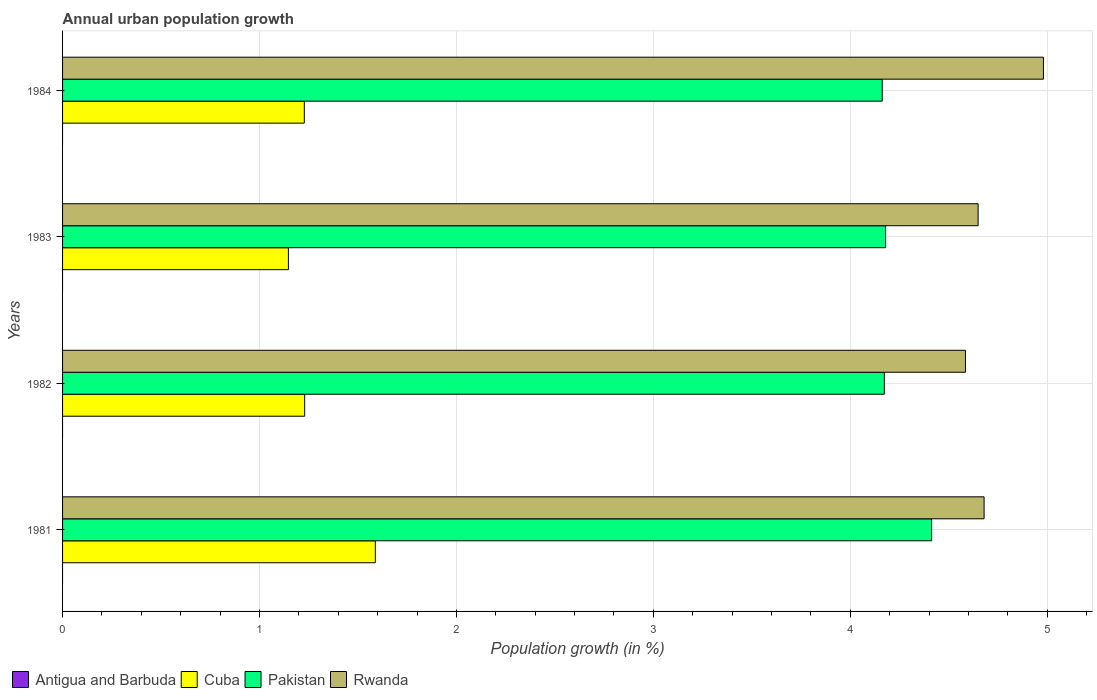Are the number of bars on each tick of the Y-axis equal?
Keep it short and to the point. Yes. What is the label of the 1st group of bars from the top?
Your answer should be very brief. 1984. In how many cases, is the number of bars for a given year not equal to the number of legend labels?
Keep it short and to the point. 4. What is the percentage of urban population growth in Cuba in 1981?
Provide a short and direct response. 1.59. Across all years, what is the maximum percentage of urban population growth in Cuba?
Make the answer very short. 1.59. Across all years, what is the minimum percentage of urban population growth in Rwanda?
Offer a terse response. 4.58. What is the total percentage of urban population growth in Rwanda in the graph?
Ensure brevity in your answer.  18.89. What is the difference between the percentage of urban population growth in Rwanda in 1981 and that in 1982?
Give a very brief answer. 0.09. What is the difference between the percentage of urban population growth in Cuba in 1982 and the percentage of urban population growth in Rwanda in 1984?
Make the answer very short. -3.75. What is the average percentage of urban population growth in Rwanda per year?
Give a very brief answer. 4.72. In the year 1983, what is the difference between the percentage of urban population growth in Rwanda and percentage of urban population growth in Cuba?
Keep it short and to the point. 3.5. What is the ratio of the percentage of urban population growth in Pakistan in 1982 to that in 1983?
Your response must be concise. 1. Is the percentage of urban population growth in Pakistan in 1982 less than that in 1984?
Offer a terse response. No. Is the difference between the percentage of urban population growth in Rwanda in 1981 and 1982 greater than the difference between the percentage of urban population growth in Cuba in 1981 and 1982?
Make the answer very short. No. What is the difference between the highest and the second highest percentage of urban population growth in Pakistan?
Give a very brief answer. 0.23. What is the difference between the highest and the lowest percentage of urban population growth in Rwanda?
Give a very brief answer. 0.4. In how many years, is the percentage of urban population growth in Cuba greater than the average percentage of urban population growth in Cuba taken over all years?
Give a very brief answer. 1. Is the sum of the percentage of urban population growth in Rwanda in 1981 and 1984 greater than the maximum percentage of urban population growth in Pakistan across all years?
Your response must be concise. Yes. Is it the case that in every year, the sum of the percentage of urban population growth in Antigua and Barbuda and percentage of urban population growth in Cuba is greater than the percentage of urban population growth in Pakistan?
Offer a terse response. No. Are all the bars in the graph horizontal?
Give a very brief answer. Yes. What is the difference between two consecutive major ticks on the X-axis?
Your answer should be very brief. 1. Does the graph contain grids?
Provide a succinct answer. Yes. How many legend labels are there?
Make the answer very short. 4. What is the title of the graph?
Ensure brevity in your answer.  Annual urban population growth. What is the label or title of the X-axis?
Your answer should be very brief. Population growth (in %). What is the Population growth (in %) in Cuba in 1981?
Provide a short and direct response. 1.59. What is the Population growth (in %) in Pakistan in 1981?
Ensure brevity in your answer.  4.41. What is the Population growth (in %) of Rwanda in 1981?
Make the answer very short. 4.68. What is the Population growth (in %) in Cuba in 1982?
Your answer should be compact. 1.23. What is the Population growth (in %) of Pakistan in 1982?
Provide a succinct answer. 4.17. What is the Population growth (in %) in Rwanda in 1982?
Provide a succinct answer. 4.58. What is the Population growth (in %) of Cuba in 1983?
Your answer should be very brief. 1.15. What is the Population growth (in %) of Pakistan in 1983?
Offer a very short reply. 4.18. What is the Population growth (in %) of Rwanda in 1983?
Offer a terse response. 4.65. What is the Population growth (in %) in Cuba in 1984?
Make the answer very short. 1.23. What is the Population growth (in %) of Pakistan in 1984?
Ensure brevity in your answer.  4.16. What is the Population growth (in %) in Rwanda in 1984?
Provide a succinct answer. 4.98. Across all years, what is the maximum Population growth (in %) of Cuba?
Give a very brief answer. 1.59. Across all years, what is the maximum Population growth (in %) of Pakistan?
Your answer should be very brief. 4.41. Across all years, what is the maximum Population growth (in %) of Rwanda?
Provide a succinct answer. 4.98. Across all years, what is the minimum Population growth (in %) in Cuba?
Make the answer very short. 1.15. Across all years, what is the minimum Population growth (in %) of Pakistan?
Your answer should be very brief. 4.16. Across all years, what is the minimum Population growth (in %) in Rwanda?
Keep it short and to the point. 4.58. What is the total Population growth (in %) in Cuba in the graph?
Give a very brief answer. 5.19. What is the total Population growth (in %) in Pakistan in the graph?
Make the answer very short. 16.93. What is the total Population growth (in %) in Rwanda in the graph?
Your response must be concise. 18.89. What is the difference between the Population growth (in %) of Cuba in 1981 and that in 1982?
Offer a terse response. 0.36. What is the difference between the Population growth (in %) in Pakistan in 1981 and that in 1982?
Your answer should be compact. 0.24. What is the difference between the Population growth (in %) in Rwanda in 1981 and that in 1982?
Offer a terse response. 0.09. What is the difference between the Population growth (in %) in Cuba in 1981 and that in 1983?
Your answer should be very brief. 0.44. What is the difference between the Population growth (in %) in Pakistan in 1981 and that in 1983?
Keep it short and to the point. 0.23. What is the difference between the Population growth (in %) in Rwanda in 1981 and that in 1983?
Give a very brief answer. 0.03. What is the difference between the Population growth (in %) in Cuba in 1981 and that in 1984?
Your answer should be compact. 0.36. What is the difference between the Population growth (in %) in Pakistan in 1981 and that in 1984?
Provide a succinct answer. 0.25. What is the difference between the Population growth (in %) of Rwanda in 1981 and that in 1984?
Your answer should be very brief. -0.3. What is the difference between the Population growth (in %) of Cuba in 1982 and that in 1983?
Offer a very short reply. 0.08. What is the difference between the Population growth (in %) in Pakistan in 1982 and that in 1983?
Keep it short and to the point. -0.01. What is the difference between the Population growth (in %) of Rwanda in 1982 and that in 1983?
Give a very brief answer. -0.06. What is the difference between the Population growth (in %) of Cuba in 1982 and that in 1984?
Provide a short and direct response. 0. What is the difference between the Population growth (in %) of Pakistan in 1982 and that in 1984?
Ensure brevity in your answer.  0.01. What is the difference between the Population growth (in %) of Rwanda in 1982 and that in 1984?
Make the answer very short. -0.4. What is the difference between the Population growth (in %) of Cuba in 1983 and that in 1984?
Offer a very short reply. -0.08. What is the difference between the Population growth (in %) in Pakistan in 1983 and that in 1984?
Provide a short and direct response. 0.02. What is the difference between the Population growth (in %) in Rwanda in 1983 and that in 1984?
Provide a short and direct response. -0.33. What is the difference between the Population growth (in %) of Cuba in 1981 and the Population growth (in %) of Pakistan in 1982?
Offer a very short reply. -2.58. What is the difference between the Population growth (in %) of Cuba in 1981 and the Population growth (in %) of Rwanda in 1982?
Give a very brief answer. -3. What is the difference between the Population growth (in %) in Pakistan in 1981 and the Population growth (in %) in Rwanda in 1982?
Give a very brief answer. -0.17. What is the difference between the Population growth (in %) in Cuba in 1981 and the Population growth (in %) in Pakistan in 1983?
Provide a succinct answer. -2.59. What is the difference between the Population growth (in %) of Cuba in 1981 and the Population growth (in %) of Rwanda in 1983?
Offer a very short reply. -3.06. What is the difference between the Population growth (in %) of Pakistan in 1981 and the Population growth (in %) of Rwanda in 1983?
Your answer should be very brief. -0.24. What is the difference between the Population growth (in %) of Cuba in 1981 and the Population growth (in %) of Pakistan in 1984?
Offer a terse response. -2.57. What is the difference between the Population growth (in %) of Cuba in 1981 and the Population growth (in %) of Rwanda in 1984?
Keep it short and to the point. -3.39. What is the difference between the Population growth (in %) of Pakistan in 1981 and the Population growth (in %) of Rwanda in 1984?
Provide a short and direct response. -0.57. What is the difference between the Population growth (in %) in Cuba in 1982 and the Population growth (in %) in Pakistan in 1983?
Provide a succinct answer. -2.95. What is the difference between the Population growth (in %) of Cuba in 1982 and the Population growth (in %) of Rwanda in 1983?
Offer a very short reply. -3.42. What is the difference between the Population growth (in %) in Pakistan in 1982 and the Population growth (in %) in Rwanda in 1983?
Offer a terse response. -0.48. What is the difference between the Population growth (in %) in Cuba in 1982 and the Population growth (in %) in Pakistan in 1984?
Give a very brief answer. -2.93. What is the difference between the Population growth (in %) of Cuba in 1982 and the Population growth (in %) of Rwanda in 1984?
Provide a short and direct response. -3.75. What is the difference between the Population growth (in %) in Pakistan in 1982 and the Population growth (in %) in Rwanda in 1984?
Your response must be concise. -0.81. What is the difference between the Population growth (in %) in Cuba in 1983 and the Population growth (in %) in Pakistan in 1984?
Give a very brief answer. -3.02. What is the difference between the Population growth (in %) of Cuba in 1983 and the Population growth (in %) of Rwanda in 1984?
Give a very brief answer. -3.83. What is the difference between the Population growth (in %) of Pakistan in 1983 and the Population growth (in %) of Rwanda in 1984?
Your answer should be very brief. -0.8. What is the average Population growth (in %) in Antigua and Barbuda per year?
Offer a terse response. 0. What is the average Population growth (in %) of Cuba per year?
Give a very brief answer. 1.3. What is the average Population growth (in %) in Pakistan per year?
Provide a succinct answer. 4.23. What is the average Population growth (in %) in Rwanda per year?
Make the answer very short. 4.72. In the year 1981, what is the difference between the Population growth (in %) in Cuba and Population growth (in %) in Pakistan?
Offer a terse response. -2.82. In the year 1981, what is the difference between the Population growth (in %) in Cuba and Population growth (in %) in Rwanda?
Your response must be concise. -3.09. In the year 1981, what is the difference between the Population growth (in %) of Pakistan and Population growth (in %) of Rwanda?
Make the answer very short. -0.27. In the year 1982, what is the difference between the Population growth (in %) in Cuba and Population growth (in %) in Pakistan?
Your answer should be very brief. -2.94. In the year 1982, what is the difference between the Population growth (in %) in Cuba and Population growth (in %) in Rwanda?
Keep it short and to the point. -3.36. In the year 1982, what is the difference between the Population growth (in %) of Pakistan and Population growth (in %) of Rwanda?
Give a very brief answer. -0.41. In the year 1983, what is the difference between the Population growth (in %) of Cuba and Population growth (in %) of Pakistan?
Provide a short and direct response. -3.03. In the year 1983, what is the difference between the Population growth (in %) in Cuba and Population growth (in %) in Rwanda?
Your response must be concise. -3.5. In the year 1983, what is the difference between the Population growth (in %) of Pakistan and Population growth (in %) of Rwanda?
Make the answer very short. -0.47. In the year 1984, what is the difference between the Population growth (in %) of Cuba and Population growth (in %) of Pakistan?
Offer a very short reply. -2.93. In the year 1984, what is the difference between the Population growth (in %) of Cuba and Population growth (in %) of Rwanda?
Your answer should be compact. -3.75. In the year 1984, what is the difference between the Population growth (in %) of Pakistan and Population growth (in %) of Rwanda?
Provide a succinct answer. -0.82. What is the ratio of the Population growth (in %) in Cuba in 1981 to that in 1982?
Your response must be concise. 1.29. What is the ratio of the Population growth (in %) of Pakistan in 1981 to that in 1982?
Offer a very short reply. 1.06. What is the ratio of the Population growth (in %) of Rwanda in 1981 to that in 1982?
Your answer should be compact. 1.02. What is the ratio of the Population growth (in %) of Cuba in 1981 to that in 1983?
Your response must be concise. 1.38. What is the ratio of the Population growth (in %) in Pakistan in 1981 to that in 1983?
Your answer should be very brief. 1.06. What is the ratio of the Population growth (in %) of Rwanda in 1981 to that in 1983?
Ensure brevity in your answer.  1.01. What is the ratio of the Population growth (in %) in Cuba in 1981 to that in 1984?
Offer a very short reply. 1.29. What is the ratio of the Population growth (in %) of Pakistan in 1981 to that in 1984?
Provide a short and direct response. 1.06. What is the ratio of the Population growth (in %) in Rwanda in 1981 to that in 1984?
Offer a very short reply. 0.94. What is the ratio of the Population growth (in %) in Cuba in 1982 to that in 1983?
Your response must be concise. 1.07. What is the ratio of the Population growth (in %) in Pakistan in 1982 to that in 1983?
Keep it short and to the point. 1. What is the ratio of the Population growth (in %) of Rwanda in 1982 to that in 1983?
Provide a short and direct response. 0.99. What is the ratio of the Population growth (in %) of Cuba in 1982 to that in 1984?
Provide a succinct answer. 1. What is the ratio of the Population growth (in %) of Rwanda in 1982 to that in 1984?
Provide a succinct answer. 0.92. What is the ratio of the Population growth (in %) in Cuba in 1983 to that in 1984?
Offer a terse response. 0.93. What is the ratio of the Population growth (in %) in Rwanda in 1983 to that in 1984?
Give a very brief answer. 0.93. What is the difference between the highest and the second highest Population growth (in %) in Cuba?
Make the answer very short. 0.36. What is the difference between the highest and the second highest Population growth (in %) in Pakistan?
Your answer should be very brief. 0.23. What is the difference between the highest and the second highest Population growth (in %) in Rwanda?
Ensure brevity in your answer.  0.3. What is the difference between the highest and the lowest Population growth (in %) of Cuba?
Provide a short and direct response. 0.44. What is the difference between the highest and the lowest Population growth (in %) of Pakistan?
Provide a succinct answer. 0.25. What is the difference between the highest and the lowest Population growth (in %) in Rwanda?
Make the answer very short. 0.4. 